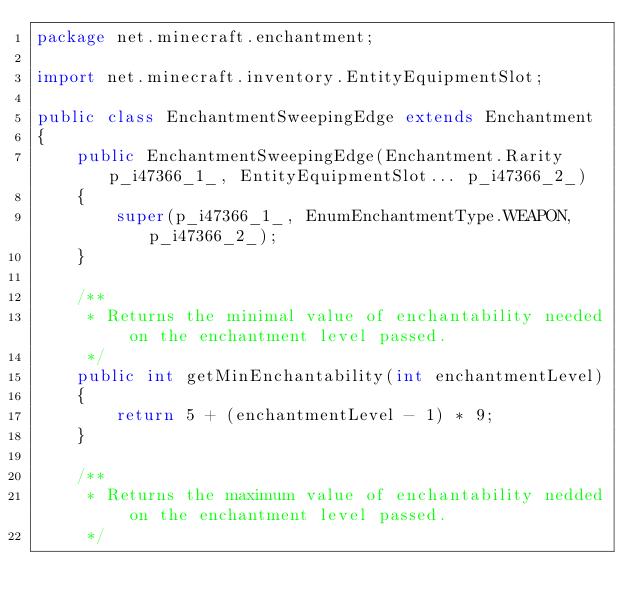Convert code to text. <code><loc_0><loc_0><loc_500><loc_500><_Java_>package net.minecraft.enchantment;

import net.minecraft.inventory.EntityEquipmentSlot;

public class EnchantmentSweepingEdge extends Enchantment
{
    public EnchantmentSweepingEdge(Enchantment.Rarity p_i47366_1_, EntityEquipmentSlot... p_i47366_2_)
    {
        super(p_i47366_1_, EnumEnchantmentType.WEAPON, p_i47366_2_);
    }

    /**
     * Returns the minimal value of enchantability needed on the enchantment level passed.
     */
    public int getMinEnchantability(int enchantmentLevel)
    {
        return 5 + (enchantmentLevel - 1) * 9;
    }

    /**
     * Returns the maximum value of enchantability nedded on the enchantment level passed.
     */</code> 